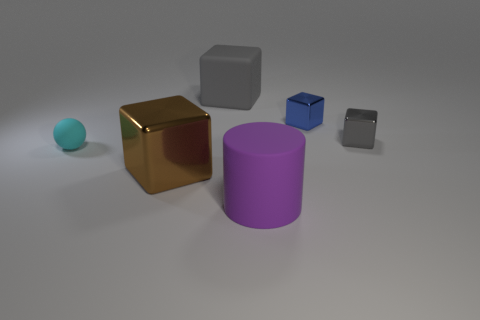What is the size of the metallic object that is the same color as the matte cube?
Your answer should be very brief. Small. How many tiny cyan objects have the same shape as the purple rubber thing?
Your answer should be very brief. 0. There is a gray object that is the same size as the matte cylinder; what shape is it?
Keep it short and to the point. Cube. Are there any matte objects right of the cyan sphere?
Your answer should be compact. Yes. There is a big rubber object in front of the tiny cyan ball; is there a small blue cube to the left of it?
Give a very brief answer. No. Are there fewer tiny cyan matte spheres that are behind the tiny blue cube than tiny blue metal blocks in front of the big metallic cube?
Ensure brevity in your answer.  No. Is there any other thing that has the same size as the rubber cube?
Your response must be concise. Yes. The blue metallic thing has what shape?
Your response must be concise. Cube. What material is the gray block on the right side of the rubber cylinder?
Give a very brief answer. Metal. How big is the cyan matte thing that is on the left side of the metal object that is on the left side of the large rubber thing in front of the tiny gray shiny thing?
Provide a succinct answer. Small. 